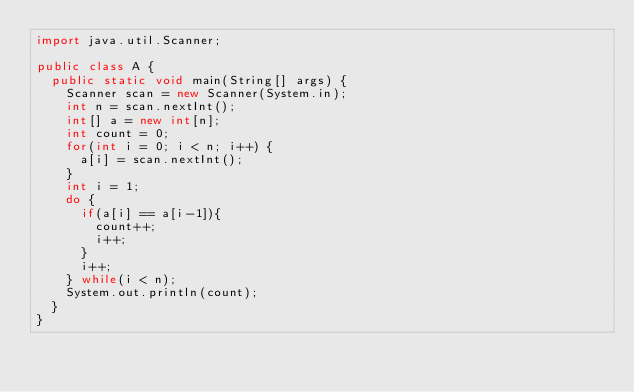Convert code to text. <code><loc_0><loc_0><loc_500><loc_500><_Java_>import java.util.Scanner;

public class A {
	public static void main(String[] args) {
		Scanner scan = new Scanner(System.in);
		int n = scan.nextInt();
		int[] a = new int[n];
		int count = 0;
		for(int i = 0; i < n; i++) {
			a[i] = scan.nextInt();
		}
		int i = 1;
		do {
			if(a[i] == a[i-1]){
				count++;
				i++;
			}
			i++;
		} while(i < n);
		System.out.println(count);
	}
}</code> 